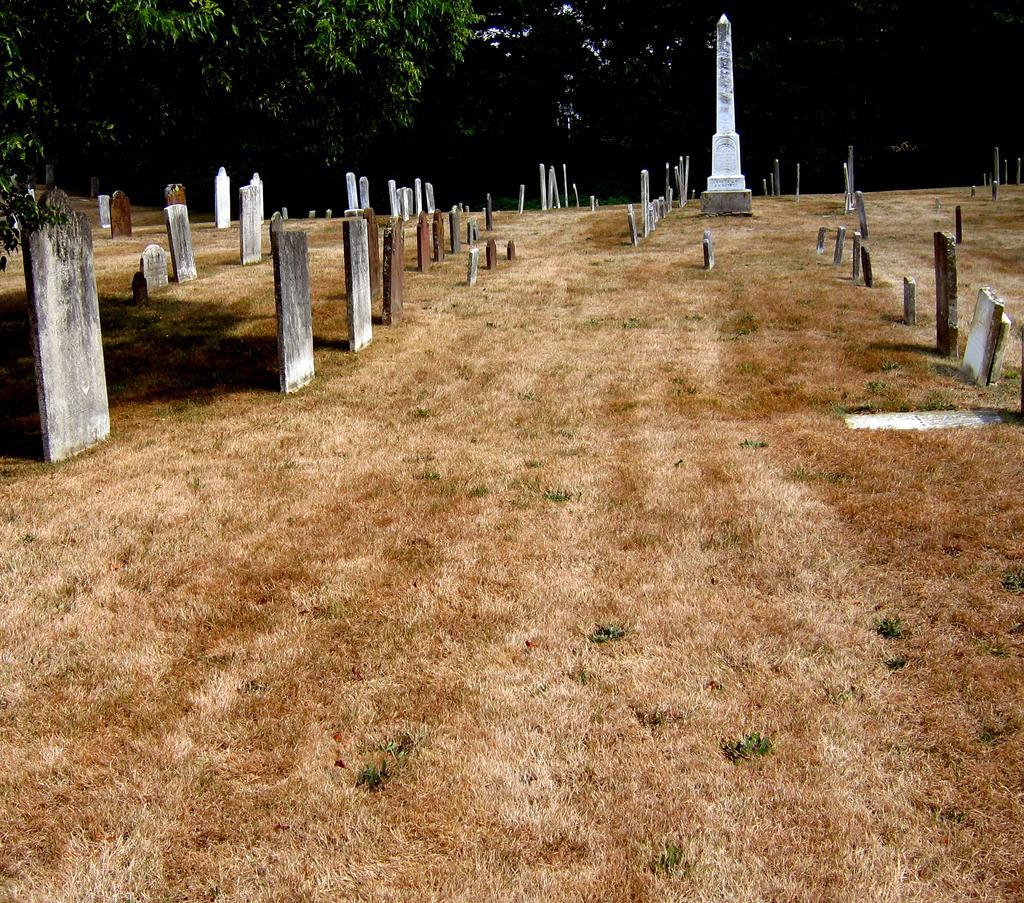Can you describe this image briefly? In this picture we can see graves and a memorial on the ground and in the background we can see trees. 